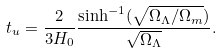Convert formula to latex. <formula><loc_0><loc_0><loc_500><loc_500>t _ { u } = \frac { 2 } { 3 H _ { 0 } } \frac { \sinh ^ { - 1 } ( \sqrt { \Omega _ { \Lambda } / \Omega _ { m } } ) } { \sqrt { \Omega _ { \Lambda } } } .</formula> 